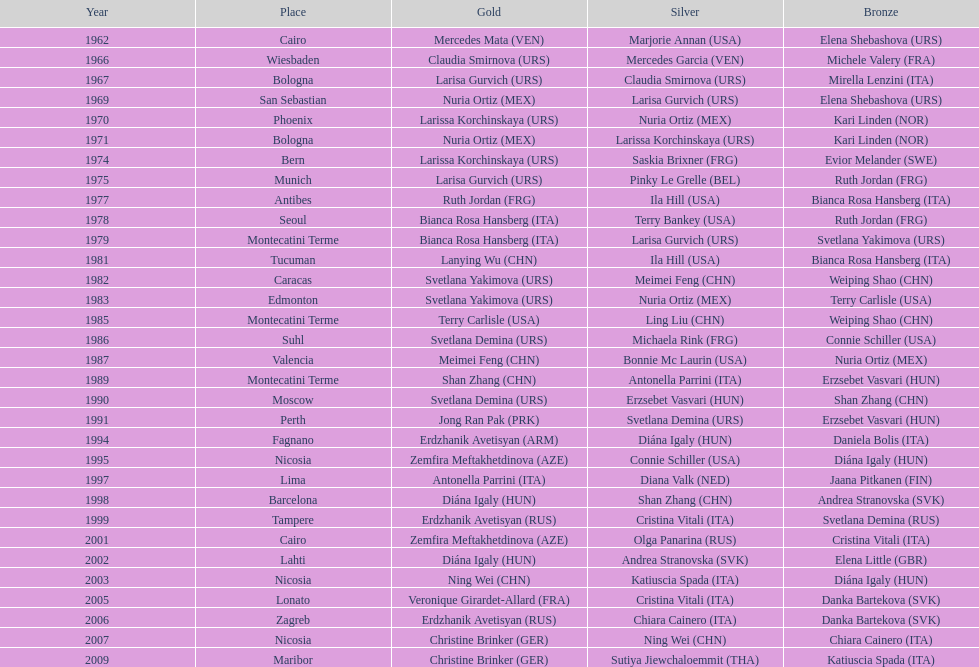Which country has the most bronze medals? Italy. 